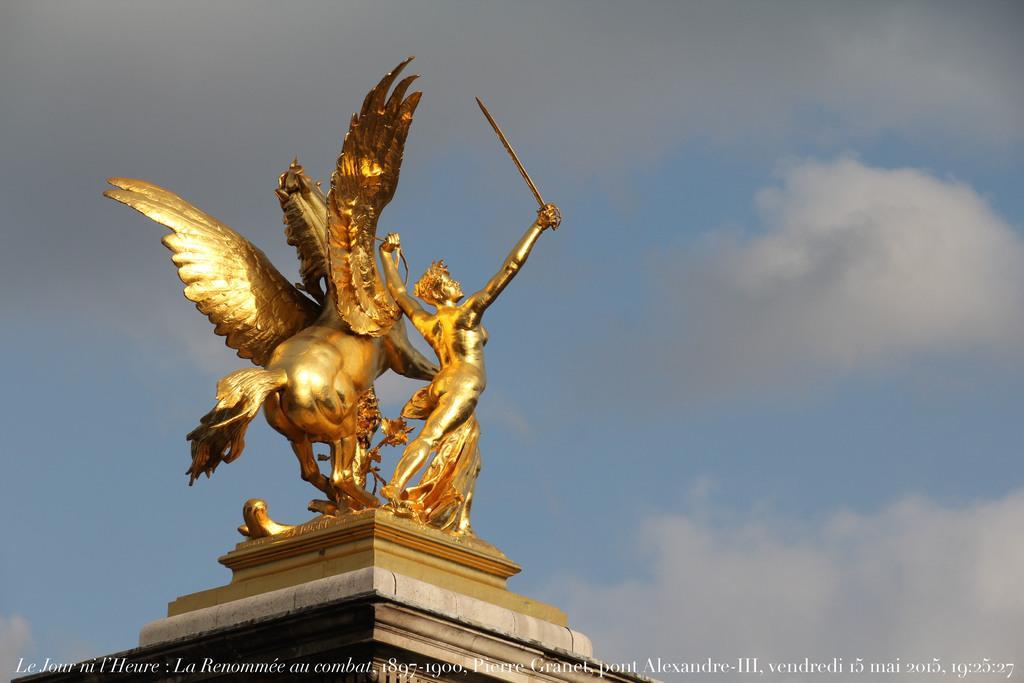Please provide a concise description of this image. In this picture we can see a statue on a platform and we can see sky in the background, at the bottom we can see some text on it. 